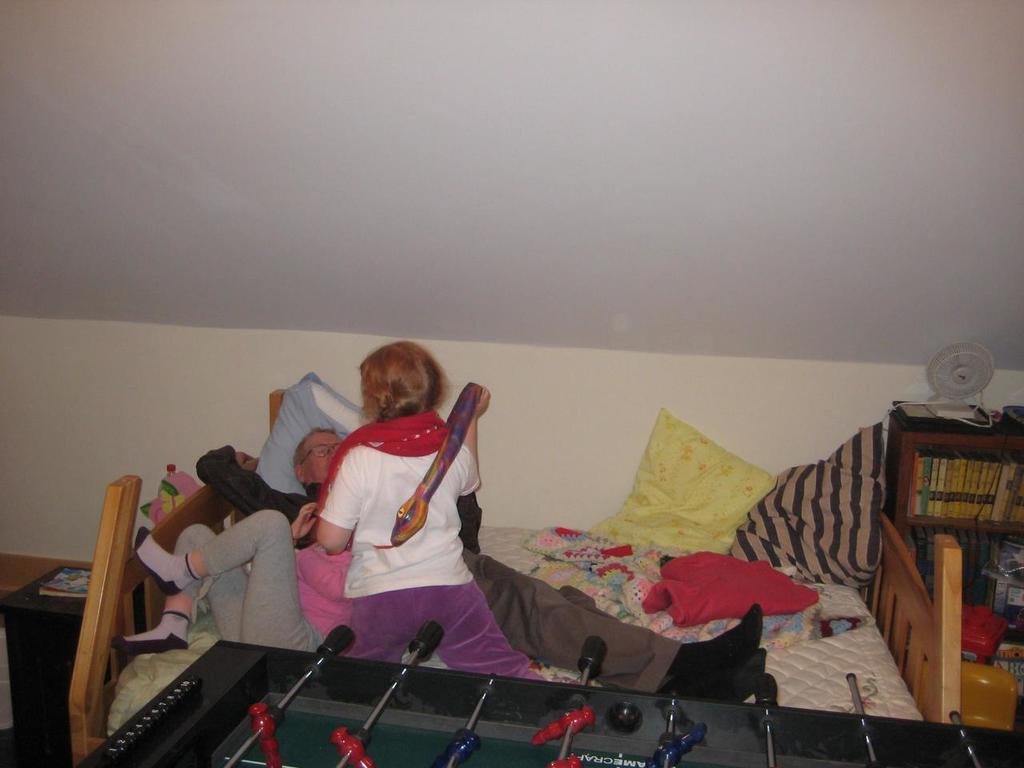Describe this image in one or two sentences. In the center we can see few persons were lying on the bed. In front there is one table. In the background we can see wall,table fan,rack,books,pillow,blanket and table. 